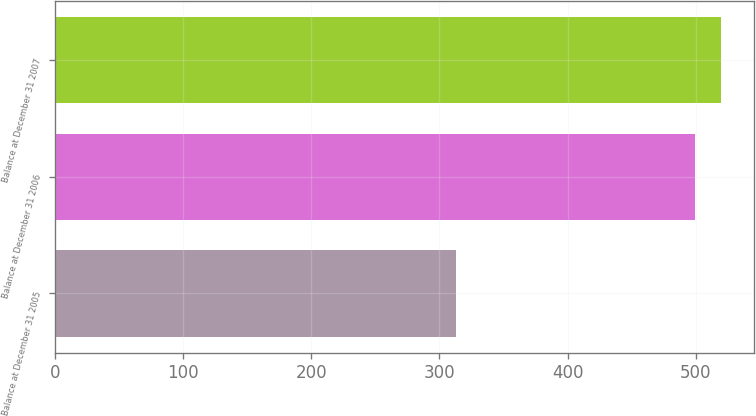Convert chart to OTSL. <chart><loc_0><loc_0><loc_500><loc_500><bar_chart><fcel>Balance at December 31 2005<fcel>Balance at December 31 2006<fcel>Balance at December 31 2007<nl><fcel>313<fcel>499.7<fcel>519.69<nl></chart> 